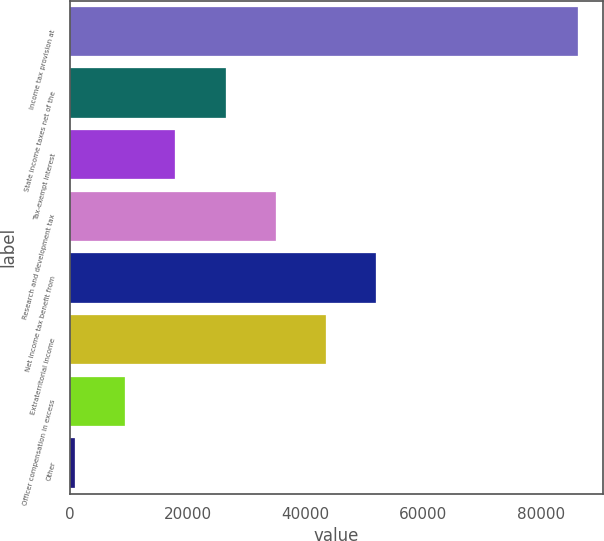Convert chart. <chart><loc_0><loc_0><loc_500><loc_500><bar_chart><fcel>Income tax provision at<fcel>State income taxes net of the<fcel>Tax-exempt interest<fcel>Research and development tax<fcel>Net income tax benefit from<fcel>Extraterritorial income<fcel>Officer compensation in excess<fcel>Other<nl><fcel>86215<fcel>26460.2<fcel>17923.8<fcel>34996.6<fcel>52069.4<fcel>43533<fcel>9387.4<fcel>851<nl></chart> 